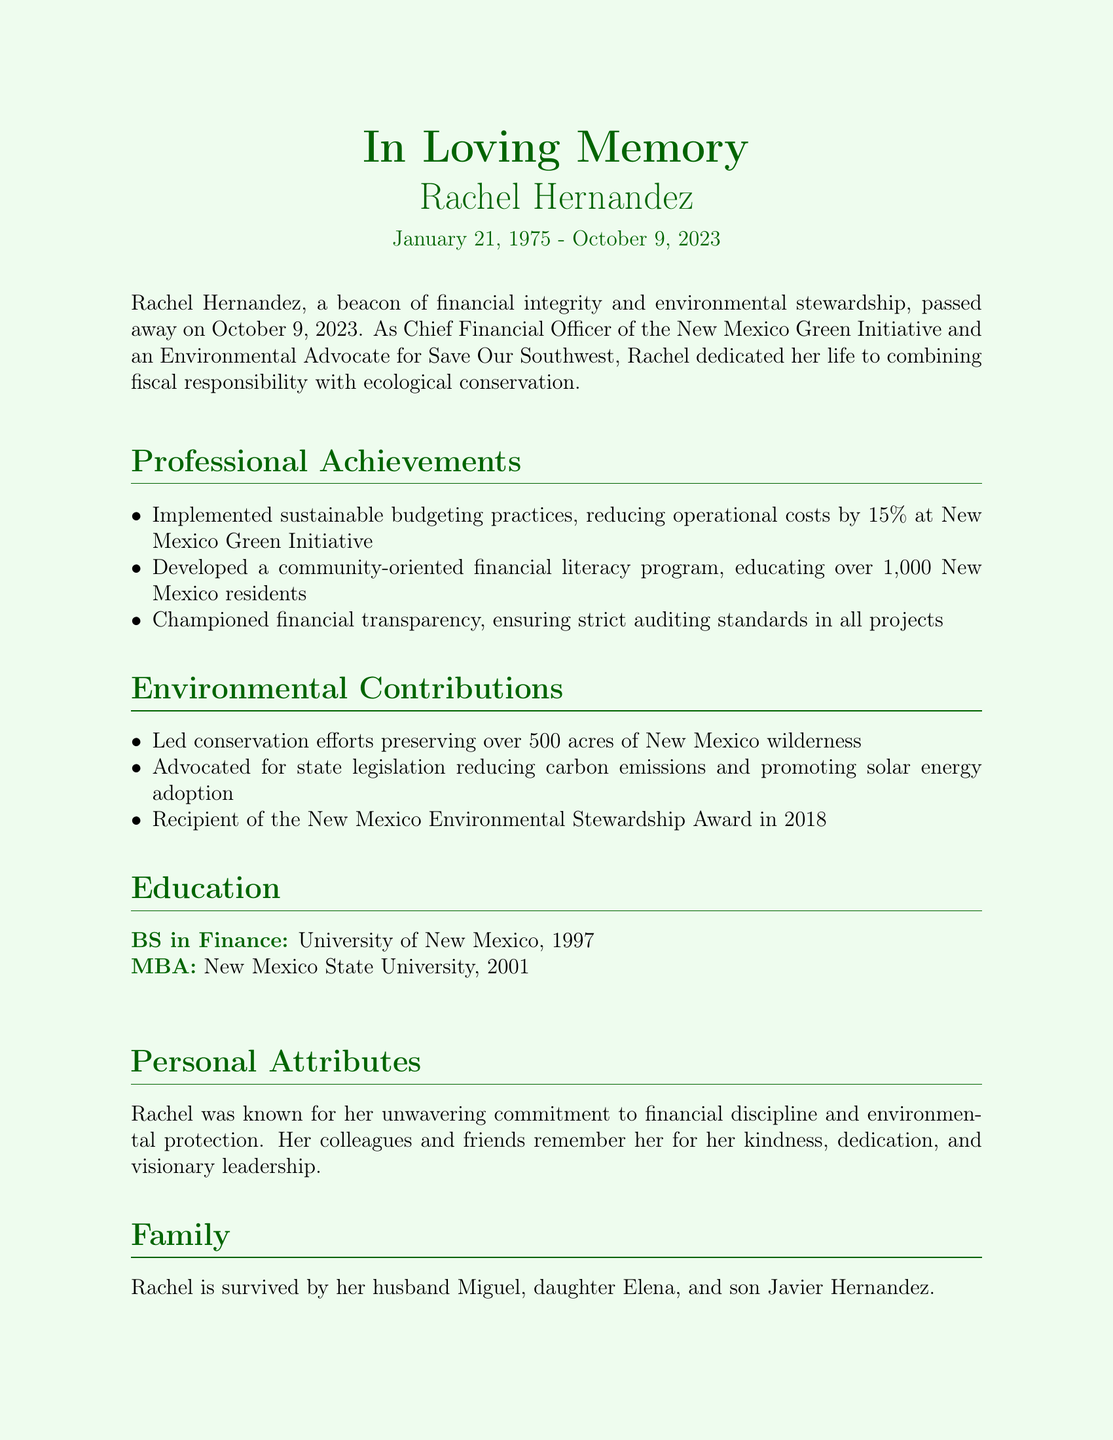What is Rachel Hernandez's birth date? Rachel Hernandez was born on January 21, 1975, as mentioned in the obituary.
Answer: January 21, 1975 When did Rachel Hernandez pass away? The obituary states that she passed away on October 9, 2023.
Answer: October 9, 2023 What role did Rachel Hernandez hold at the New Mexico Green Initiative? She was the Chief Financial Officer, as specified in the document.
Answer: Chief Financial Officer How much did Rachel's budgeting practices reduce operational costs? The document notes a 15% reduction in operational costs achieved through sustainable budgeting.
Answer: 15% What award did Rachel receive in 2018? The obituary mentions she was a recipient of the New Mexico Environmental Stewardship Award in 2018.
Answer: New Mexico Environmental Stewardship Award Who are Rachel's surviving family members? The document lists her husband Miguel, daughter Elena, and son Javier as her survivors.
Answer: Miguel, Elena, Javier What educational degree did Rachel earn from the University of New Mexico? The document states she received a BS in Finance in 1997 from the University of New Mexico.
Answer: BS in Finance What is the date and time of Rachel's funeral service? The obituary indicates the funeral service will take place on October 15, 2023, at 10:00 AM.
Answer: October 15, 2023, 10:00 AM What organizations can donations be made to in lieu of flowers? The document specifies that donations can be made to Save Our Southwest or the New Mexico Green Initiative.
Answer: Save Our Southwest or the New Mexico Green Initiative 